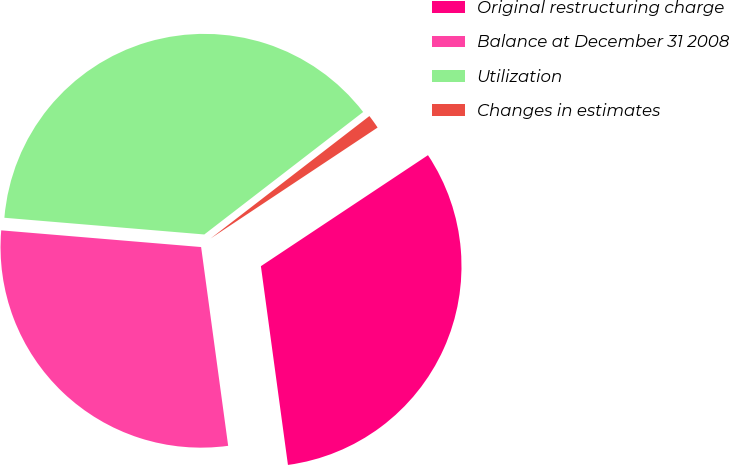Convert chart. <chart><loc_0><loc_0><loc_500><loc_500><pie_chart><fcel>Original restructuring charge<fcel>Balance at December 31 2008<fcel>Utilization<fcel>Changes in estimates<nl><fcel>32.18%<fcel>28.48%<fcel>38.22%<fcel>1.12%<nl></chart> 